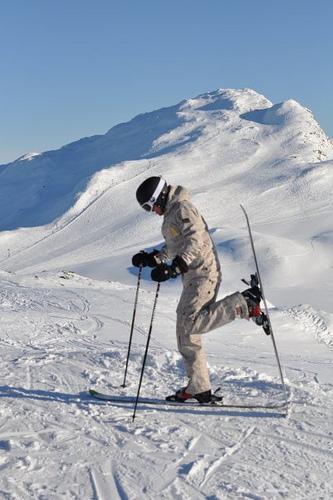How many feet are flat on the ground?
Give a very brief answer. 1. 